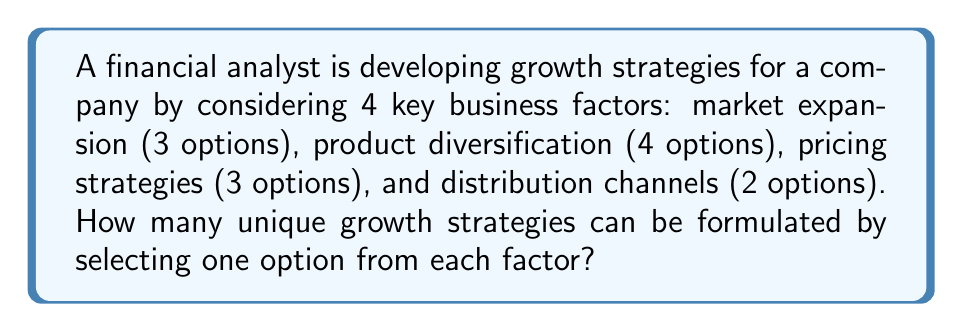What is the answer to this math problem? To solve this problem, we'll use the Multiplication Principle of Counting. This principle states that if we have a sequence of $n$ independent choices, where the $i$-th choice has $k_i$ options, then the total number of possible outcomes is the product of the number of options for each choice.

Let's break down the problem:

1. Market expansion: 3 options
2. Product diversification: 4 options
3. Pricing strategies: 3 options
4. Distribution channels: 2 options

We need to choose one option from each factor to create a unique growth strategy. Therefore, we multiply the number of options for each factor:

$$ \text{Total number of strategies} = 3 \times 4 \times 3 \times 2 $$

Calculating this:

$$ \text{Total number of strategies} = 72 $$

Thus, the financial analyst can formulate 72 unique growth strategies by combining one option from each of the four business factors.
Answer: 72 